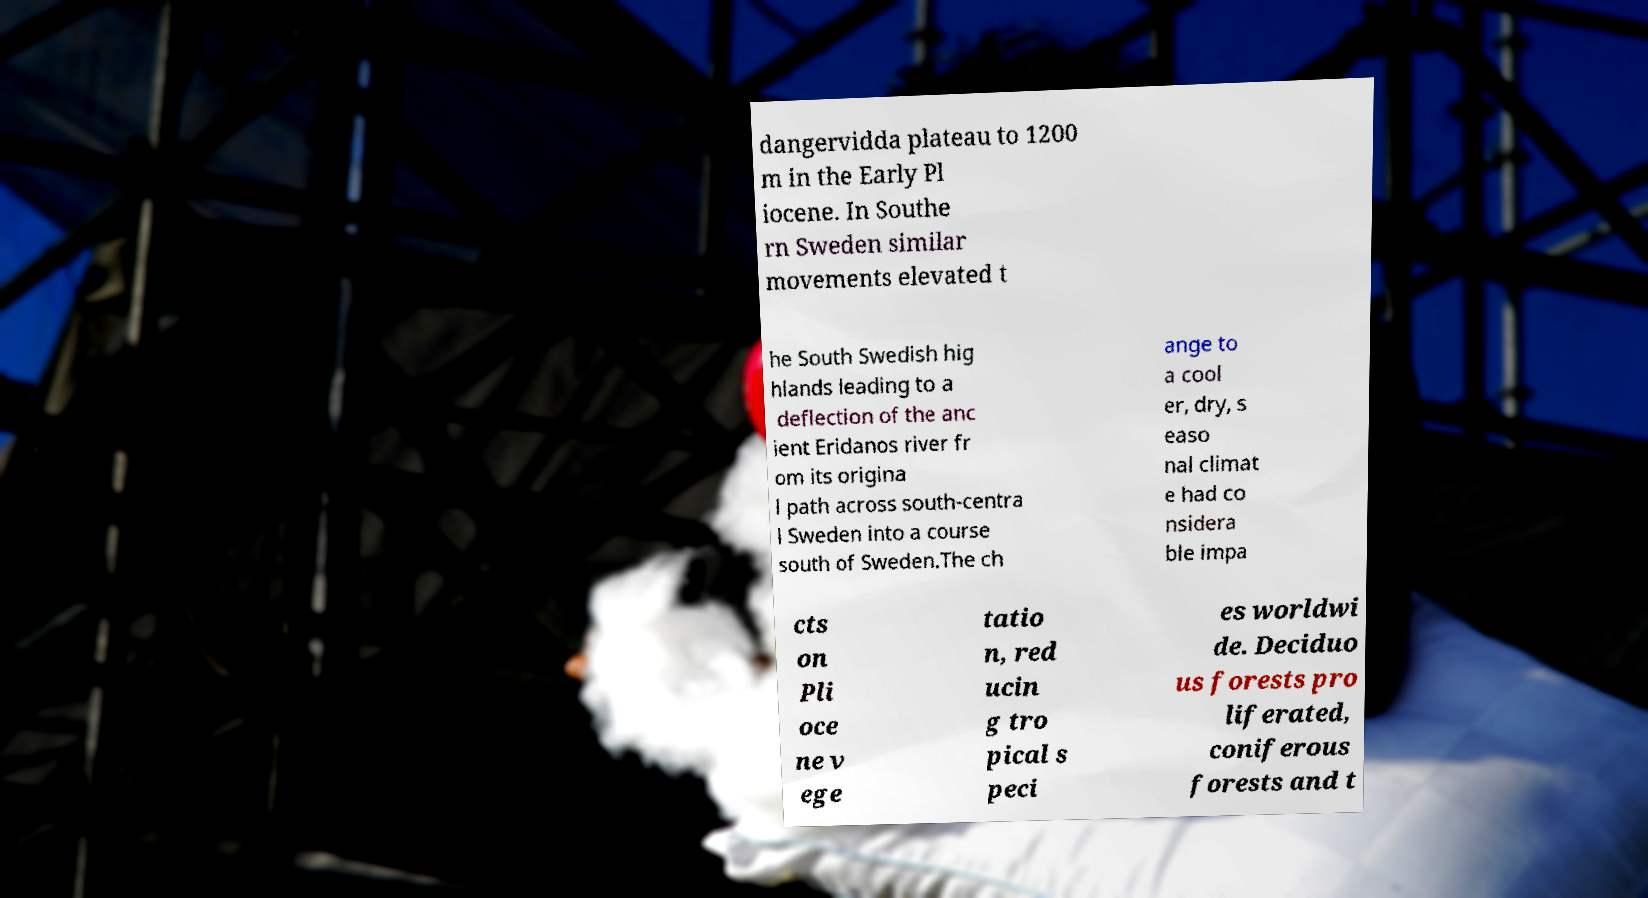I need the written content from this picture converted into text. Can you do that? dangervidda plateau to 1200 m in the Early Pl iocene. In Southe rn Sweden similar movements elevated t he South Swedish hig hlands leading to a deflection of the anc ient Eridanos river fr om its origina l path across south-centra l Sweden into a course south of Sweden.The ch ange to a cool er, dry, s easo nal climat e had co nsidera ble impa cts on Pli oce ne v ege tatio n, red ucin g tro pical s peci es worldwi de. Deciduo us forests pro liferated, coniferous forests and t 